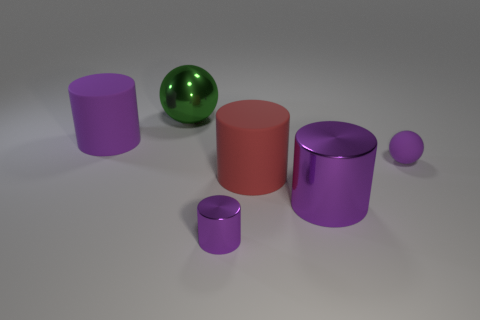There is a large metallic object that is the same color as the tiny shiny cylinder; what shape is it?
Offer a very short reply. Cylinder. Does the small metal cylinder have the same color as the tiny rubber thing?
Provide a succinct answer. Yes. There is a ball that is in front of the large purple matte cylinder; is it the same color as the small shiny thing?
Give a very brief answer. Yes. Is there a shiny thing that has the same color as the large metallic cylinder?
Offer a very short reply. Yes. There is a big rubber thing behind the small purple rubber ball; does it have the same color as the small thing that is to the left of the big red thing?
Your answer should be very brief. Yes. There is a rubber object that is the same color as the small matte ball; what is its size?
Provide a short and direct response. Large. There is a purple matte object that is in front of the purple rubber cylinder; what is its size?
Provide a short and direct response. Small. The large purple cylinder that is behind the matte thing right of the red rubber thing is made of what material?
Ensure brevity in your answer.  Rubber. How many tiny purple objects are in front of the big purple cylinder that is on the right side of the large rubber cylinder that is on the left side of the large green shiny thing?
Make the answer very short. 1. Is the material of the tiny thing left of the purple rubber ball the same as the small purple sphere to the right of the large red matte object?
Your answer should be compact. No. 